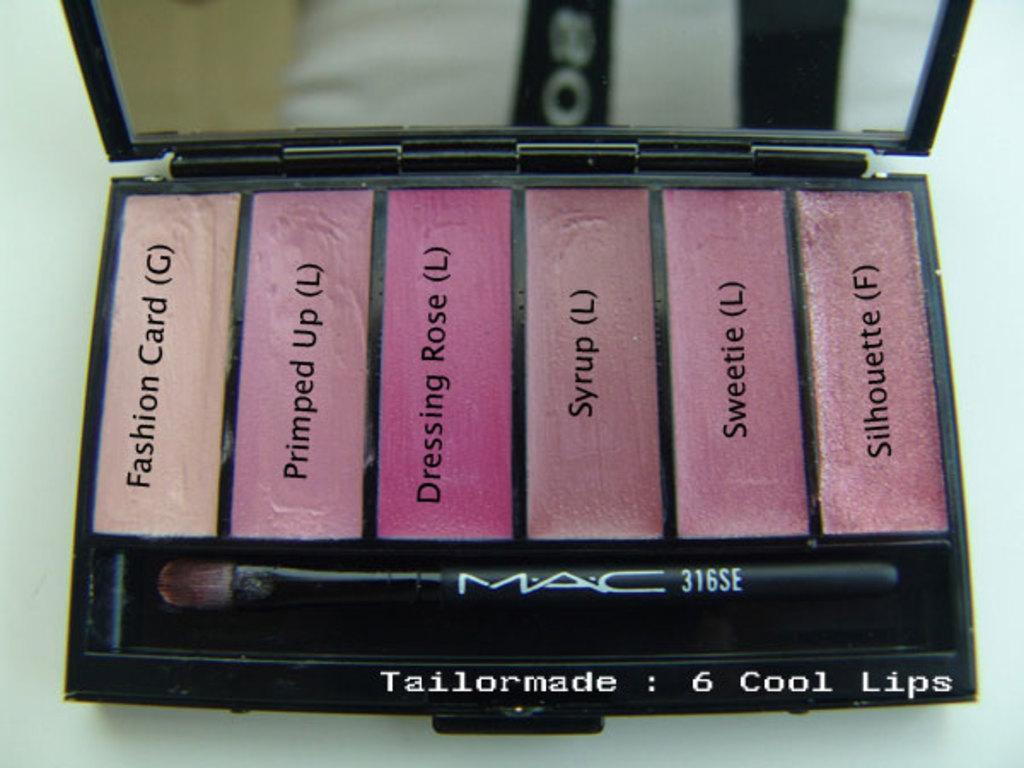How would you summarize this image in a sentence or two? In this image I can see few colorful lipsticks in the box and I can see the mirror and the brush. 